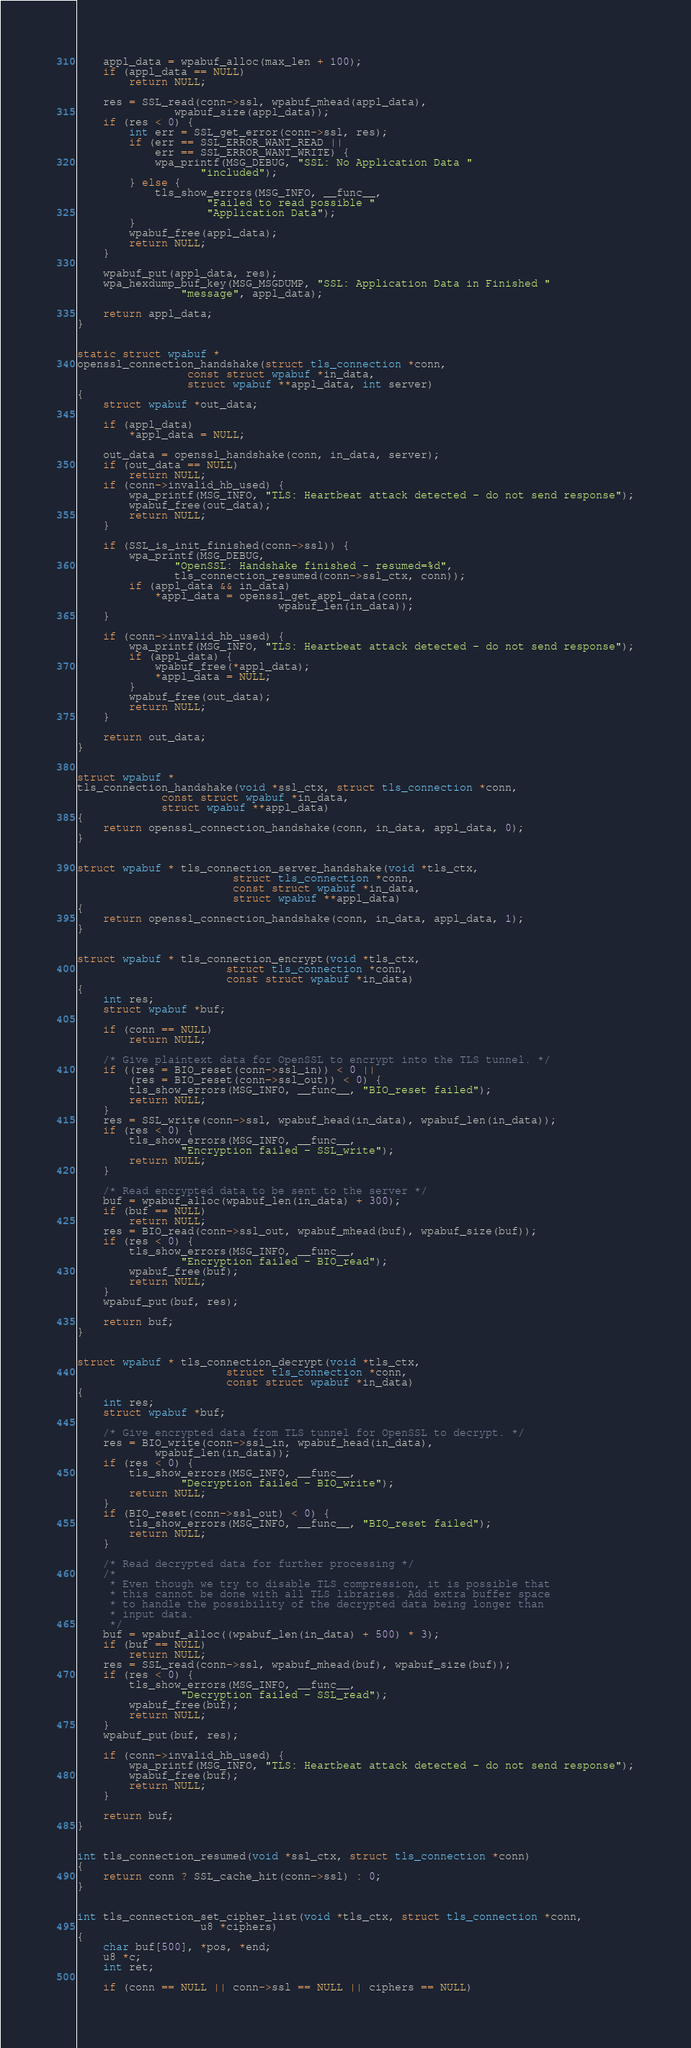Convert code to text. <code><loc_0><loc_0><loc_500><loc_500><_C_>	appl_data = wpabuf_alloc(max_len + 100);
	if (appl_data == NULL)
		return NULL;

	res = SSL_read(conn->ssl, wpabuf_mhead(appl_data),
		       wpabuf_size(appl_data));
	if (res < 0) {
		int err = SSL_get_error(conn->ssl, res);
		if (err == SSL_ERROR_WANT_READ ||
		    err == SSL_ERROR_WANT_WRITE) {
			wpa_printf(MSG_DEBUG, "SSL: No Application Data "
				   "included");
		} else {
			tls_show_errors(MSG_INFO, __func__,
					"Failed to read possible "
					"Application Data");
		}
		wpabuf_free(appl_data);
		return NULL;
	}

	wpabuf_put(appl_data, res);
	wpa_hexdump_buf_key(MSG_MSGDUMP, "SSL: Application Data in Finished "
			    "message", appl_data);

	return appl_data;
}


static struct wpabuf *
openssl_connection_handshake(struct tls_connection *conn,
			     const struct wpabuf *in_data,
			     struct wpabuf **appl_data, int server)
{
	struct wpabuf *out_data;

	if (appl_data)
		*appl_data = NULL;

	out_data = openssl_handshake(conn, in_data, server);
	if (out_data == NULL)
		return NULL;
	if (conn->invalid_hb_used) {
		wpa_printf(MSG_INFO, "TLS: Heartbeat attack detected - do not send response");
		wpabuf_free(out_data);
		return NULL;
	}

	if (SSL_is_init_finished(conn->ssl)) {
		wpa_printf(MSG_DEBUG,
			   "OpenSSL: Handshake finished - resumed=%d",
			   tls_connection_resumed(conn->ssl_ctx, conn));
		if (appl_data && in_data)
			*appl_data = openssl_get_appl_data(conn,
							   wpabuf_len(in_data));
	}

	if (conn->invalid_hb_used) {
		wpa_printf(MSG_INFO, "TLS: Heartbeat attack detected - do not send response");
		if (appl_data) {
			wpabuf_free(*appl_data);
			*appl_data = NULL;
		}
		wpabuf_free(out_data);
		return NULL;
	}

	return out_data;
}


struct wpabuf *
tls_connection_handshake(void *ssl_ctx, struct tls_connection *conn,
			 const struct wpabuf *in_data,
			 struct wpabuf **appl_data)
{
	return openssl_connection_handshake(conn, in_data, appl_data, 0);
}


struct wpabuf * tls_connection_server_handshake(void *tls_ctx,
						struct tls_connection *conn,
						const struct wpabuf *in_data,
						struct wpabuf **appl_data)
{
	return openssl_connection_handshake(conn, in_data, appl_data, 1);
}


struct wpabuf * tls_connection_encrypt(void *tls_ctx,
				       struct tls_connection *conn,
				       const struct wpabuf *in_data)
{
	int res;
	struct wpabuf *buf;

	if (conn == NULL)
		return NULL;

	/* Give plaintext data for OpenSSL to encrypt into the TLS tunnel. */
	if ((res = BIO_reset(conn->ssl_in)) < 0 ||
	    (res = BIO_reset(conn->ssl_out)) < 0) {
		tls_show_errors(MSG_INFO, __func__, "BIO_reset failed");
		return NULL;
	}
	res = SSL_write(conn->ssl, wpabuf_head(in_data), wpabuf_len(in_data));
	if (res < 0) {
		tls_show_errors(MSG_INFO, __func__,
				"Encryption failed - SSL_write");
		return NULL;
	}

	/* Read encrypted data to be sent to the server */
	buf = wpabuf_alloc(wpabuf_len(in_data) + 300);
	if (buf == NULL)
		return NULL;
	res = BIO_read(conn->ssl_out, wpabuf_mhead(buf), wpabuf_size(buf));
	if (res < 0) {
		tls_show_errors(MSG_INFO, __func__,
				"Encryption failed - BIO_read");
		wpabuf_free(buf);
		return NULL;
	}
	wpabuf_put(buf, res);

	return buf;
}


struct wpabuf * tls_connection_decrypt(void *tls_ctx,
				       struct tls_connection *conn,
				       const struct wpabuf *in_data)
{
	int res;
	struct wpabuf *buf;

	/* Give encrypted data from TLS tunnel for OpenSSL to decrypt. */
	res = BIO_write(conn->ssl_in, wpabuf_head(in_data),
			wpabuf_len(in_data));
	if (res < 0) {
		tls_show_errors(MSG_INFO, __func__,
				"Decryption failed - BIO_write");
		return NULL;
	}
	if (BIO_reset(conn->ssl_out) < 0) {
		tls_show_errors(MSG_INFO, __func__, "BIO_reset failed");
		return NULL;
	}

	/* Read decrypted data for further processing */
	/*
	 * Even though we try to disable TLS compression, it is possible that
	 * this cannot be done with all TLS libraries. Add extra buffer space
	 * to handle the possibility of the decrypted data being longer than
	 * input data.
	 */
	buf = wpabuf_alloc((wpabuf_len(in_data) + 500) * 3);
	if (buf == NULL)
		return NULL;
	res = SSL_read(conn->ssl, wpabuf_mhead(buf), wpabuf_size(buf));
	if (res < 0) {
		tls_show_errors(MSG_INFO, __func__,
				"Decryption failed - SSL_read");
		wpabuf_free(buf);
		return NULL;
	}
	wpabuf_put(buf, res);

	if (conn->invalid_hb_used) {
		wpa_printf(MSG_INFO, "TLS: Heartbeat attack detected - do not send response");
		wpabuf_free(buf);
		return NULL;
	}

	return buf;
}


int tls_connection_resumed(void *ssl_ctx, struct tls_connection *conn)
{
	return conn ? SSL_cache_hit(conn->ssl) : 0;
}


int tls_connection_set_cipher_list(void *tls_ctx, struct tls_connection *conn,
				   u8 *ciphers)
{
	char buf[500], *pos, *end;
	u8 *c;
	int ret;

	if (conn == NULL || conn->ssl == NULL || ciphers == NULL)</code> 